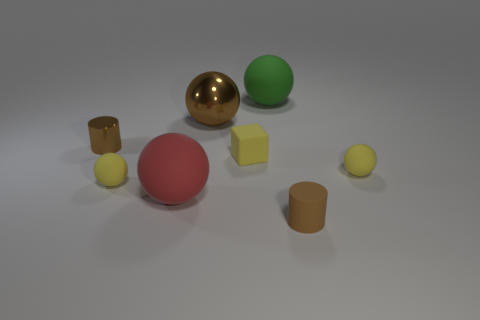There is a big green thing; how many tiny brown objects are to the right of it?
Offer a very short reply. 1. The cube has what size?
Offer a terse response. Small. Do the small sphere left of the large green matte thing and the small brown thing left of the large green ball have the same material?
Your response must be concise. No. Is there a rubber thing of the same color as the tiny cube?
Ensure brevity in your answer.  Yes. What color is the matte cylinder that is the same size as the yellow rubber block?
Offer a very short reply. Brown. Do the small cylinder left of the large green rubber thing and the large shiny ball have the same color?
Your response must be concise. Yes. Are there any big green spheres made of the same material as the big red thing?
Make the answer very short. Yes. What shape is the matte thing that is the same color as the big metallic object?
Your response must be concise. Cylinder. Are there fewer metal cylinders left of the tiny brown shiny thing than brown shiny cylinders?
Your answer should be very brief. Yes. Is the size of the yellow object that is left of the yellow matte block the same as the green matte thing?
Make the answer very short. No. 